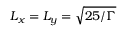Convert formula to latex. <formula><loc_0><loc_0><loc_500><loc_500>L _ { x } = L _ { y } = \sqrt { 2 5 / \Gamma }</formula> 